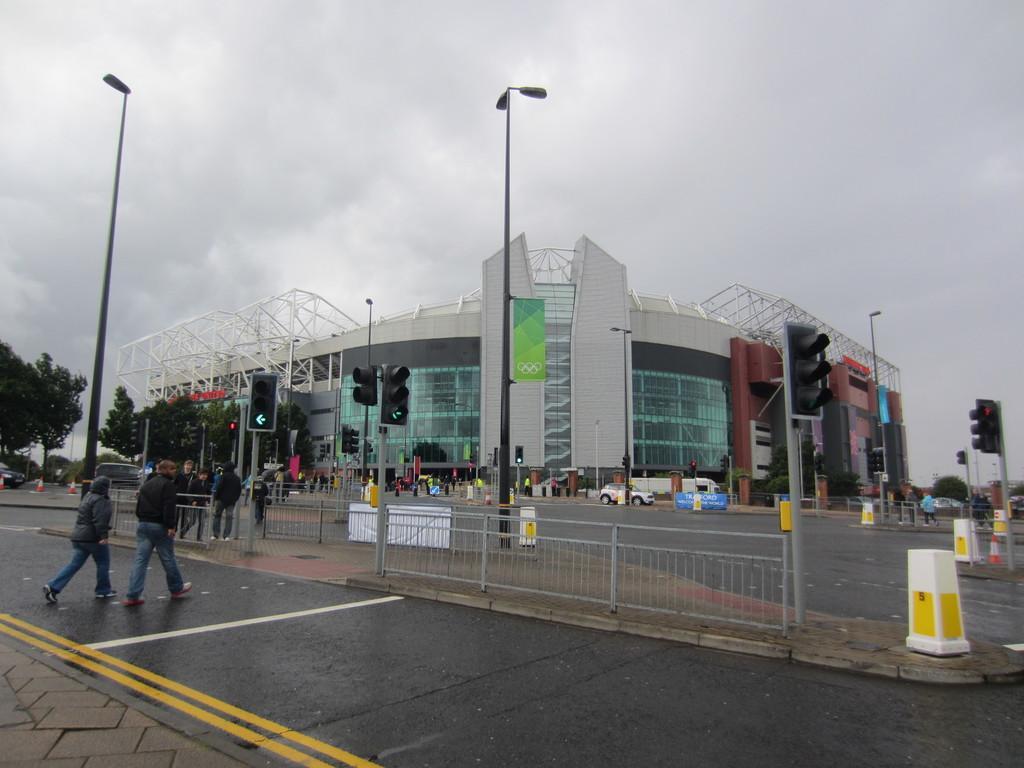In one or two sentences, can you explain what this image depicts? In this picture i can see buildings, street lights, traffic lights, barricades and some other objects. Here I can see trees, people are standing on the road. In the background I can see the sky. 